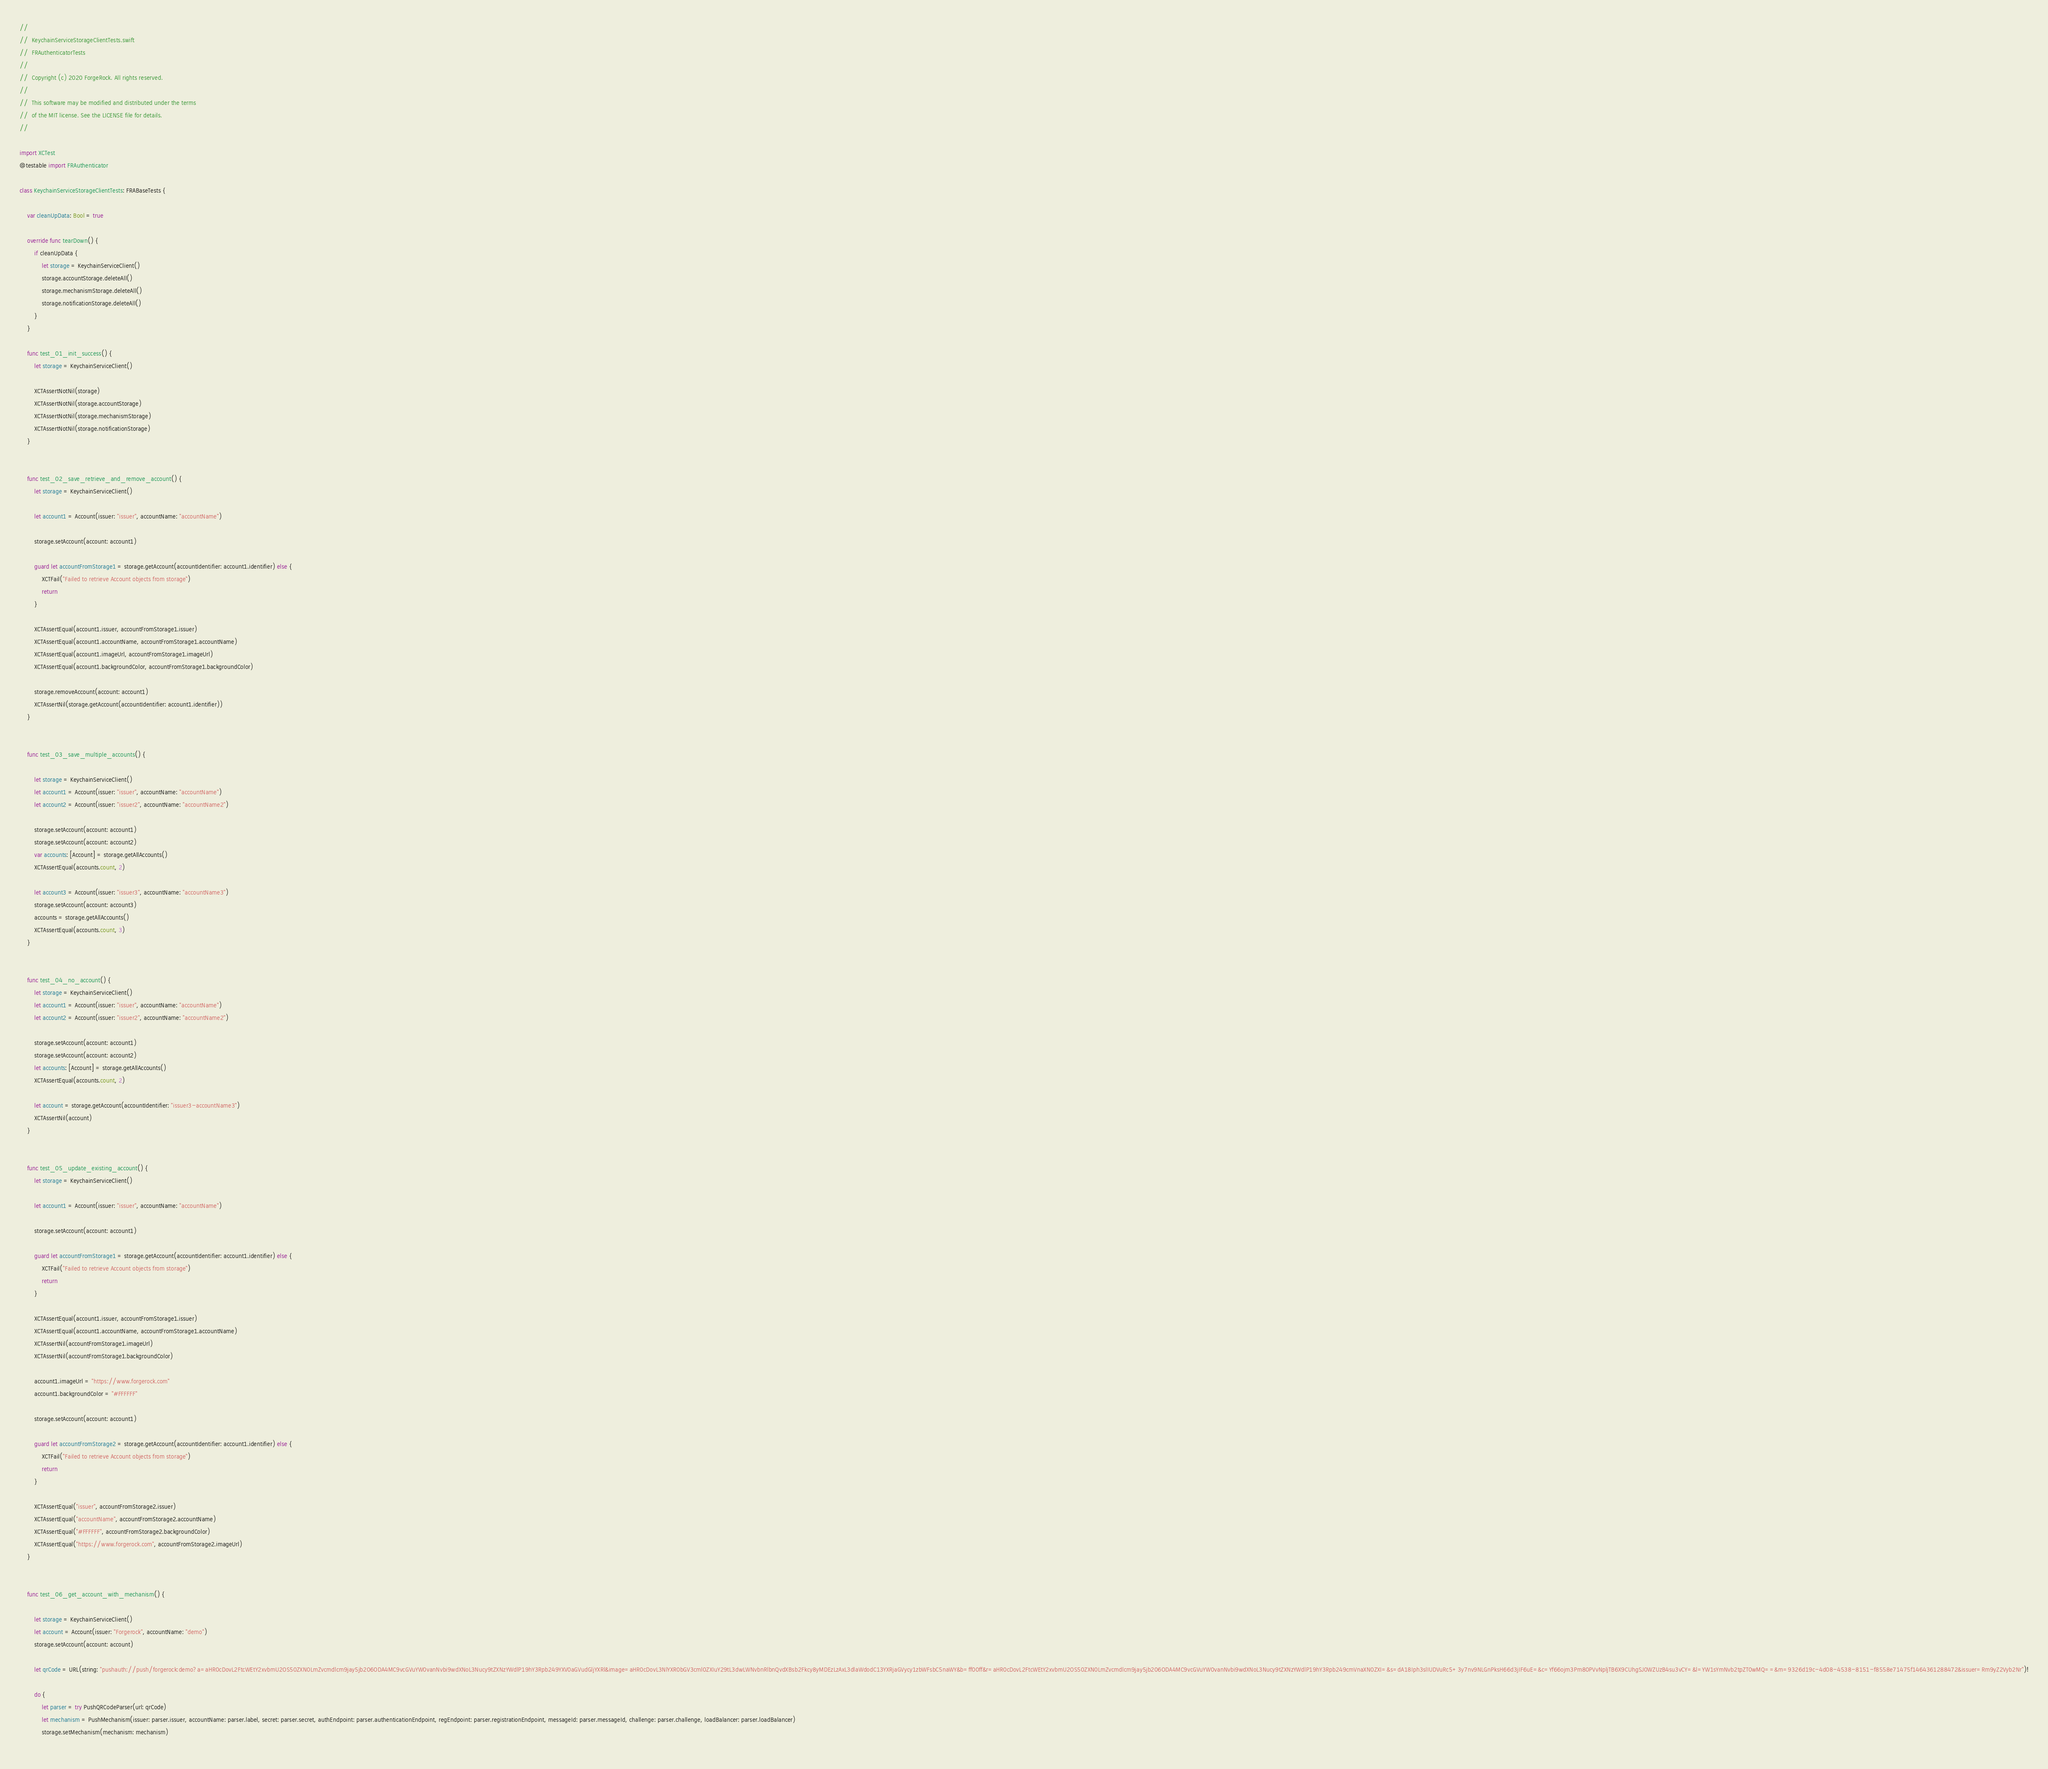Convert code to text. <code><loc_0><loc_0><loc_500><loc_500><_Swift_>// 
//  KeychainServiceStorageClientTests.swift
//  FRAuthenticatorTests
//
//  Copyright (c) 2020 ForgeRock. All rights reserved.
//
//  This software may be modified and distributed under the terms
//  of the MIT license. See the LICENSE file for details.
//

import XCTest
@testable import FRAuthenticator

class KeychainServiceStorageClientTests: FRABaseTests {

    var cleanUpData: Bool = true
    
    override func tearDown() {
        if cleanUpData {
            let storage = KeychainServiceClient()
            storage.accountStorage.deleteAll()
            storage.mechanismStorage.deleteAll()
            storage.notificationStorage.deleteAll()
        }
    }
    
    func test_01_init_success() {
        let storage = KeychainServiceClient()
        
        XCTAssertNotNil(storage)
        XCTAssertNotNil(storage.accountStorage)
        XCTAssertNotNil(storage.mechanismStorage)
        XCTAssertNotNil(storage.notificationStorage)
    }
    
    
    func test_02_save_retrieve_and_remove_account() {
        let storage = KeychainServiceClient()
        
        let account1 = Account(issuer: "issuer", accountName: "accountName")
        
        storage.setAccount(account: account1)
        
        guard let accountFromStorage1 = storage.getAccount(accountIdentifier: account1.identifier) else {
            XCTFail("Failed to retrieve Account objects from storage")
            return
        }
        
        XCTAssertEqual(account1.issuer, accountFromStorage1.issuer)
        XCTAssertEqual(account1.accountName, accountFromStorage1.accountName)
        XCTAssertEqual(account1.imageUrl, accountFromStorage1.imageUrl)
        XCTAssertEqual(account1.backgroundColor, accountFromStorage1.backgroundColor)
        
        storage.removeAccount(account: account1)
        XCTAssertNil(storage.getAccount(accountIdentifier: account1.identifier))
    }
    
    
    func test_03_save_multiple_accounts() {
        
        let storage = KeychainServiceClient()
        let account1 = Account(issuer: "issuer", accountName: "accountName")
        let account2 = Account(issuer: "issuer2", accountName: "accountName2")
        
        storage.setAccount(account: account1)
        storage.setAccount(account: account2)
        var accounts: [Account] = storage.getAllAccounts()
        XCTAssertEqual(accounts.count, 2)

        let account3 = Account(issuer: "issuer3", accountName: "accountName3")
        storage.setAccount(account: account3)
        accounts = storage.getAllAccounts()
        XCTAssertEqual(accounts.count, 3)
    }
    
    
    func test_04_no_account() {
        let storage = KeychainServiceClient()
        let account1 = Account(issuer: "issuer", accountName: "accountName")
        let account2 = Account(issuer: "issuer2", accountName: "accountName2")
        
        storage.setAccount(account: account1)
        storage.setAccount(account: account2)
        let accounts: [Account] = storage.getAllAccounts()
        XCTAssertEqual(accounts.count, 2)
        
        let account = storage.getAccount(accountIdentifier: "issuer3-accountName3")
        XCTAssertNil(account)
    }
    
    
    func test_05_update_existing_account() {
        let storage = KeychainServiceClient()
        
        let account1 = Account(issuer: "issuer", accountName: "accountName")
        
        storage.setAccount(account: account1)
        
        guard let accountFromStorage1 = storage.getAccount(accountIdentifier: account1.identifier) else {
            XCTFail("Failed to retrieve Account objects from storage")
            return
        }
        
        XCTAssertEqual(account1.issuer, accountFromStorage1.issuer)
        XCTAssertEqual(account1.accountName, accountFromStorage1.accountName)
        XCTAssertNil(accountFromStorage1.imageUrl)
        XCTAssertNil(accountFromStorage1.backgroundColor)
        
        account1.imageUrl = "https://www.forgerock.com"
        account1.backgroundColor = "#FFFFFF"
        
        storage.setAccount(account: account1)
        
        guard let accountFromStorage2 = storage.getAccount(accountIdentifier: account1.identifier) else {
            XCTFail("Failed to retrieve Account objects from storage")
            return
        }
        
        XCTAssertEqual("issuer", accountFromStorage2.issuer)
        XCTAssertEqual("accountName", accountFromStorage2.accountName)
        XCTAssertEqual("#FFFFFF", accountFromStorage2.backgroundColor)
        XCTAssertEqual("https://www.forgerock.com", accountFromStorage2.imageUrl)
    }
    
    
    func test_06_get_account_with_mechanism() {
        
        let storage = KeychainServiceClient()
        let account = Account(issuer: "Forgerock", accountName: "demo")
        storage.setAccount(account: account)
        
        let qrCode = URL(string: "pushauth://push/forgerock:demo?a=aHR0cDovL2FtcWEtY2xvbmU2OS50ZXN0LmZvcmdlcm9jay5jb206ODA4MC9vcGVuYW0vanNvbi9wdXNoL3Nucy9tZXNzYWdlP19hY3Rpb249YXV0aGVudGljYXRl&image=aHR0cDovL3NlYXR0bGV3cml0ZXIuY29tL3dwLWNvbnRlbnQvdXBsb2Fkcy8yMDEzLzAxL3dlaWdodC13YXRjaGVycy1zbWFsbC5naWY&b=ff00ff&r=aHR0cDovL2FtcWEtY2xvbmU2OS50ZXN0LmZvcmdlcm9jay5jb206ODA4MC9vcGVuYW0vanNvbi9wdXNoL3Nucy9tZXNzYWdlP19hY3Rpb249cmVnaXN0ZXI=&s=dA18Iph3slIUDVuRc5+3y7nv9NLGnPksH66d3jIF6uE=&c=Yf66ojm3Pm80PVvNpljTB6X9CUhgSJ0WZUzB4su3vCY=&l=YW1sYmNvb2tpZT0wMQ==&m=9326d19c-4d08-4538-8151-f8558e71475f1464361288472&issuer=Rm9yZ2Vyb2Nr")!
        
        do {
            let parser = try PushQRCodeParser(url: qrCode)
            let mechanism = PushMechanism(issuer: parser.issuer, accountName: parser.label, secret: parser.secret, authEndpoint: parser.authenticationEndpoint, regEndpoint: parser.registrationEndpoint, messageId: parser.messageId, challenge: parser.challenge, loadBalancer: parser.loadBalancer)
            storage.setMechanism(mechanism: mechanism)
            </code> 